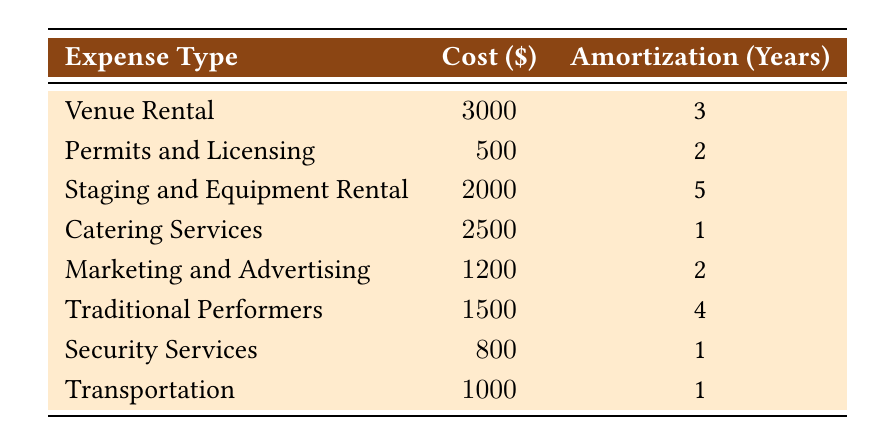What is the total cost of catering services? The table states that the cost of catering services is $2500.
Answer: 2500 Which expense has the longest amortization period? The table shows that staging and equipment rental has the longest amortization period of 5 years.
Answer: Staging and Equipment Rental What is the total cost of all expenses in the table? Summing the costs: 3000 (Venue Rental) + 500 (Permits and Licensing) + 2000 (Staging and Equipment Rental) + 2500 (Catering Services) + 1200 (Marketing and Advertising) + 1500 (Traditional Performers) + 800 (Security Services) + 1000 (Transportation) equals 13,500.
Answer: 13500 Is the cost of permits and licensing less than the cost of transportation? The cost for permits and licensing is $500 and for transportation is $1000. Since 500 is less than 1000, the answer is yes.
Answer: Yes What is the average cost of all expenses across their amortization periods? To calculate the average cost: first, sum up all the costs (3000 + 500 + 2000 + 2500 + 1200 + 1500 + 800 + 1000 = 13500) and then divide by the number of different expenses (8). Therefore, 13500 / 8 = 1687.5.
Answer: 1687.5 Which expenses have an amortization period of one year? The table lists catering services, security services, and transportation as expenses with an amortization period of one year.
Answer: Catering Services, Security Services, Transportation What is the total amortization period for all expenses? This requires summing each amortization period: 3 (Venue Rental) + 2 (Permits and Licensing) + 5 (Staging and Equipment Rental) + 1 (Catering Services) + 2 (Marketing and Advertising) + 4 (Traditional Performers) + 1 (Security Services) + 1 (Transportation) equals 19 years in total.
Answer: 19 Is the cost of traditional performers higher than the combined cost of permits and licensing plus transportation? The cost of traditional performers is $1500. The combined cost is 500 (Permits and Licensing) + 1000 (Transportation) = 1500, equating them. Therefore, the answer is no.
Answer: No What percentage of the total expenses is spent on marketing and advertising? First, find the total cost which is 13500. Marketing and advertising costs $1200. The percentage is (1200 / 13500) * 100 = 8.89%.
Answer: 8.89% 